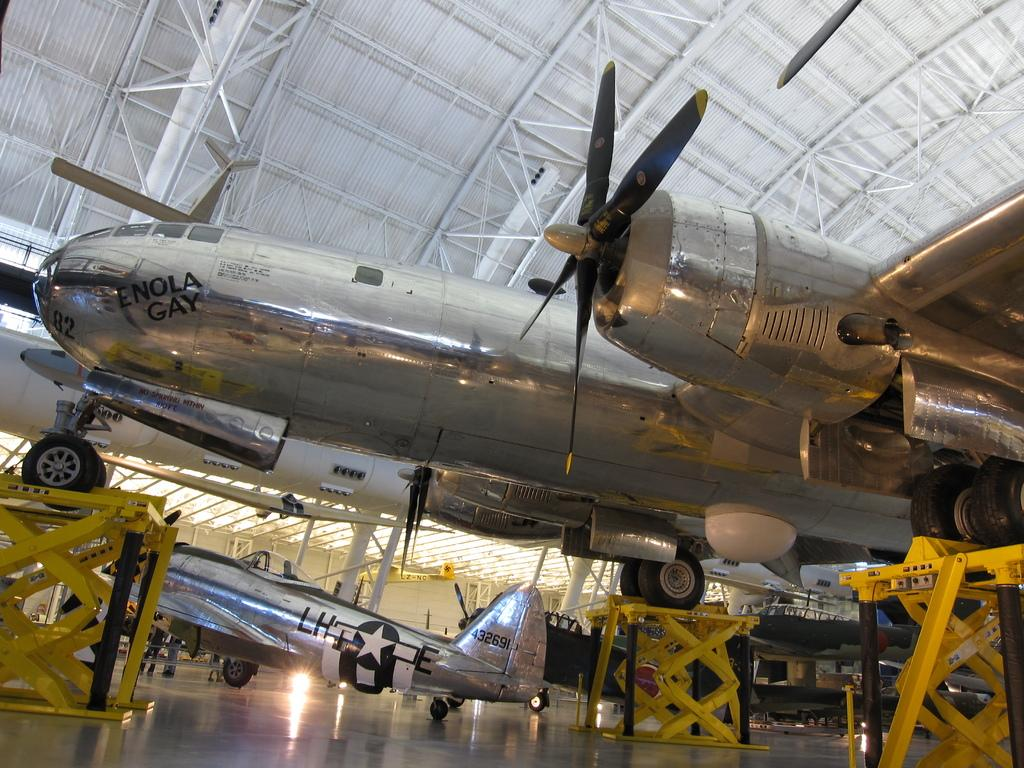What objects are placed on the floor in the image? There are aeroplanes on the floor in the image. What type of material and color are the rods in the image? The rods in the image are made of metal and are yellow in color. How many friends can be seen in the image? There are no friends present in the image. What role does the father play in the image? There is no father present in the image. 